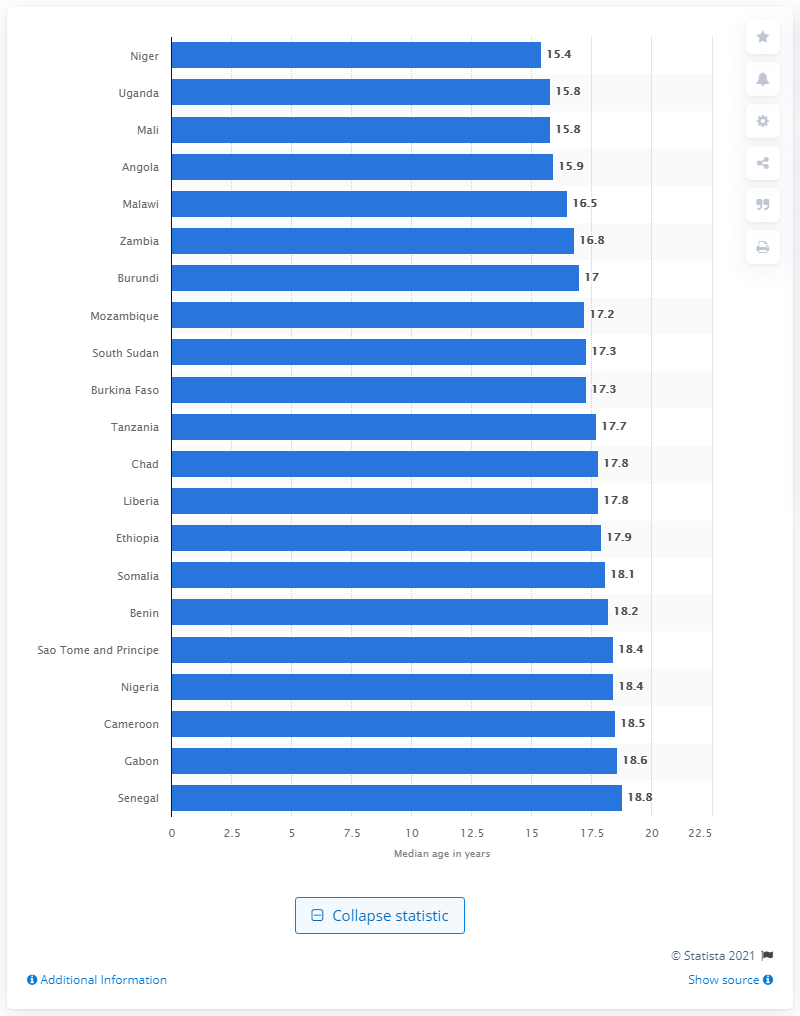Give some essential details in this illustration. Niger is the youngest country in the world. 